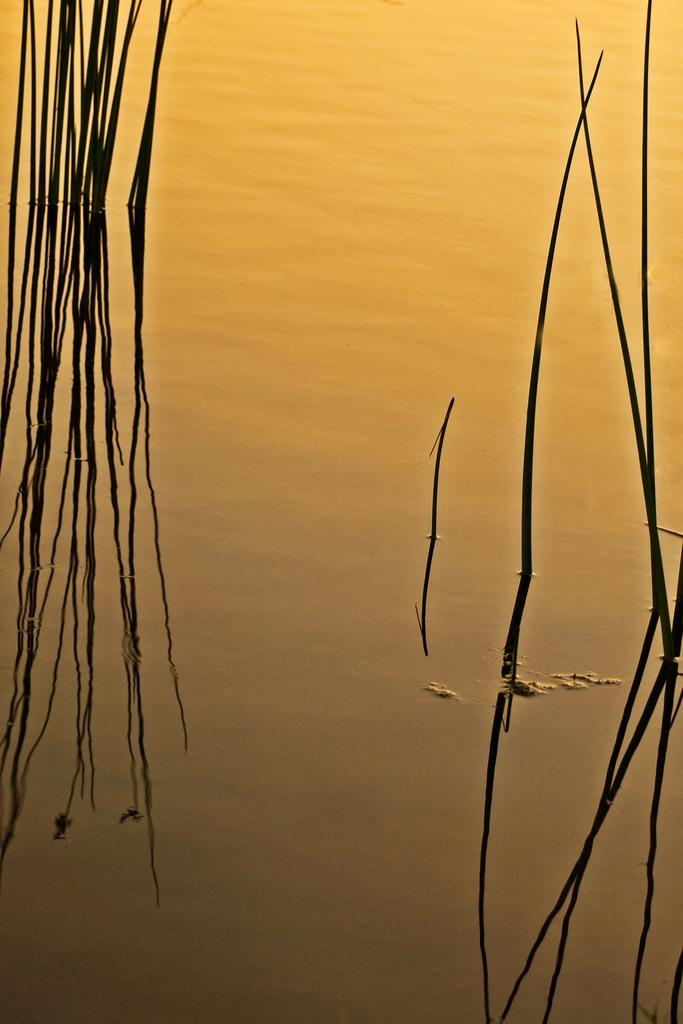What type of living organisms can be seen in the image? Plants can be seen in the image. What else is visible in the image besides the plants? There is water visible in the image. Can you see any ghosts jumping over the quince in the image? There are no ghosts or quince present in the image, so this scenario cannot be observed. 